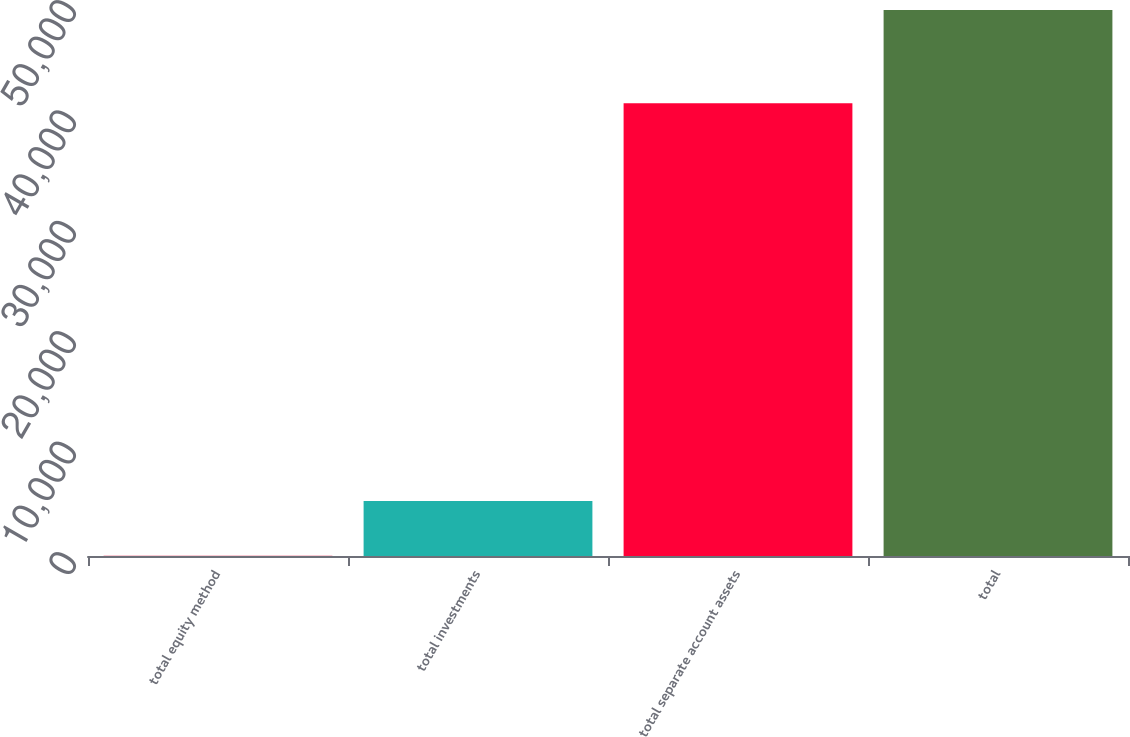Convert chart to OTSL. <chart><loc_0><loc_0><loc_500><loc_500><bar_chart><fcel>total equity method<fcel>total investments<fcel>total separate account assets<fcel>total<nl><fcel>33<fcel>4975.3<fcel>41003<fcel>49456<nl></chart> 